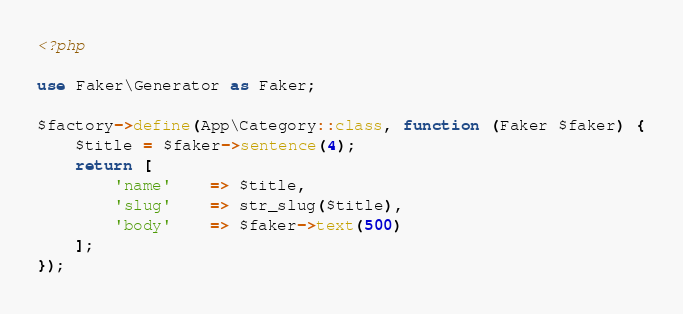Convert code to text. <code><loc_0><loc_0><loc_500><loc_500><_PHP_><?php

use Faker\Generator as Faker;

$factory->define(App\Category::class, function (Faker $faker) {
	$title = $faker->sentence(4);
    return [
        'name' 	=> $title,
        'slug'	=> str_slug($title),
        'body'	=> $faker->text(500)
    ];
});
</code> 